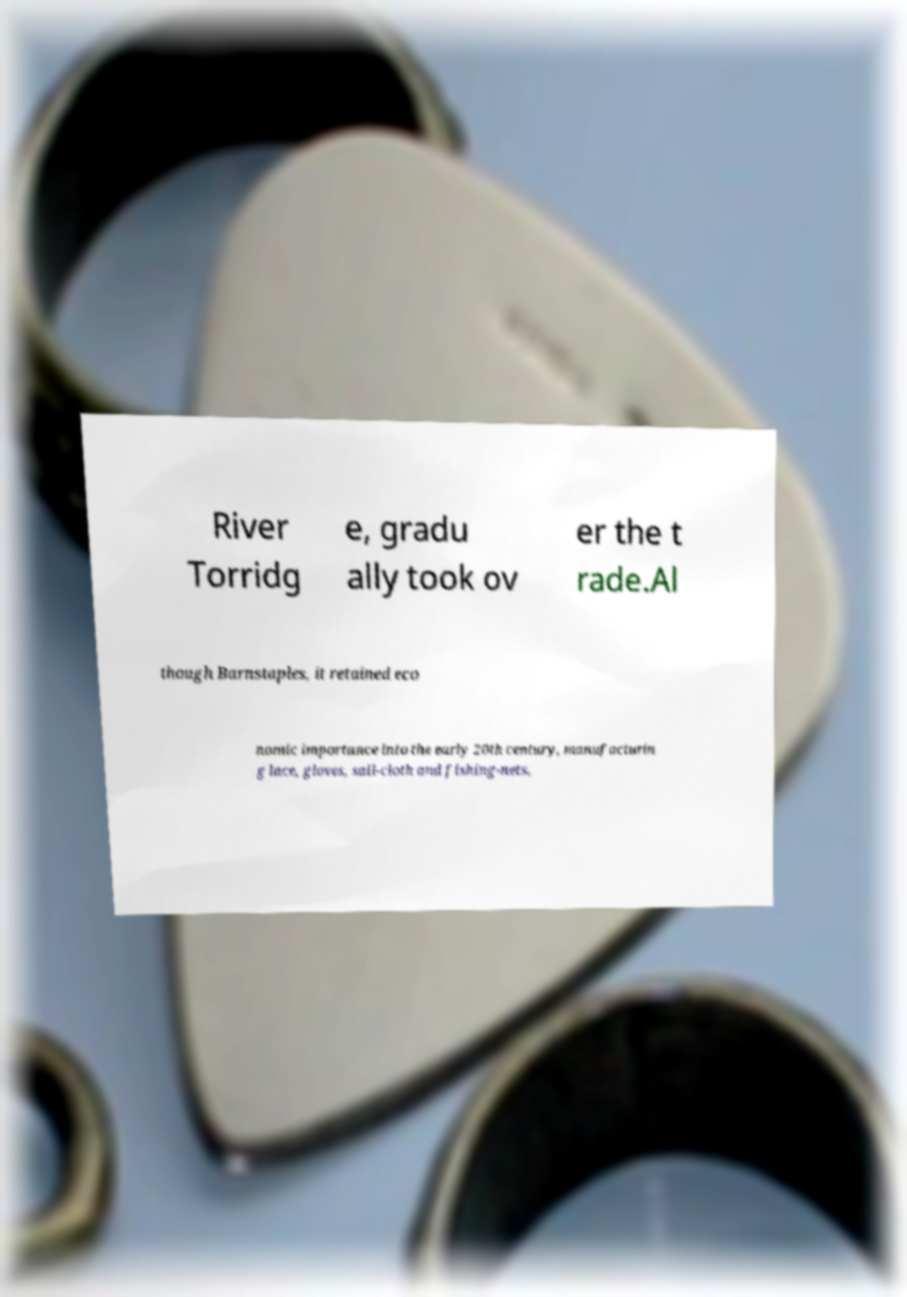Please read and relay the text visible in this image. What does it say? River Torridg e, gradu ally took ov er the t rade.Al though Barnstaples, it retained eco nomic importance into the early 20th century, manufacturin g lace, gloves, sail-cloth and fishing-nets, 